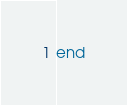<code> <loc_0><loc_0><loc_500><loc_500><_Ruby_>end
</code> 